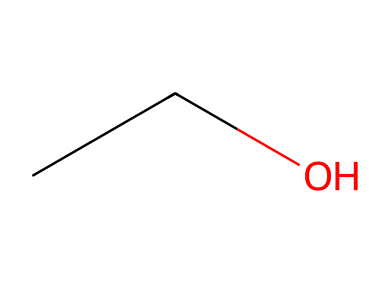What is the name of this chemical? The structure represented by the SMILES CC(O) indicates that it is ethanol, as it contains two carbon atoms linked with a hydroxyl group.
Answer: ethanol How many carbon atoms are in ethanol? The SMILES representation shows "CC," which indicates that there are two carbon atoms in the structure.
Answer: 2 What functional group is present in ethanol? In the chemical structure, the presence of the -OH group (hydroxyl group) indicates that ethanol contains an alcohol functional group.
Answer: alcohol Does ethanol contain nitrogen? The SMILES does not show any nitrogen atom in the structure. Therefore, it does not contain nitrogen.
Answer: no What is the classification of ethanol in terms of chemical type? Ethanol is classified as an alcohol due to the presence of the hydroxyl functional group.
Answer: alcohol How does the structure of ethanol affect its volatility? The presence of the hydroxyl group in ethanol allows for hydrogen bonding, which influences its volatility by making it less volatile compared to hydrocarbons without hydroxyl groups.
Answer: less volatile What is the total number of hydrogen atoms in ethanol? By considering the structure CC(O), there are five hydrogen atoms associated with the two carbon atoms and one hydroxyl group in ethanol.
Answer: 6 